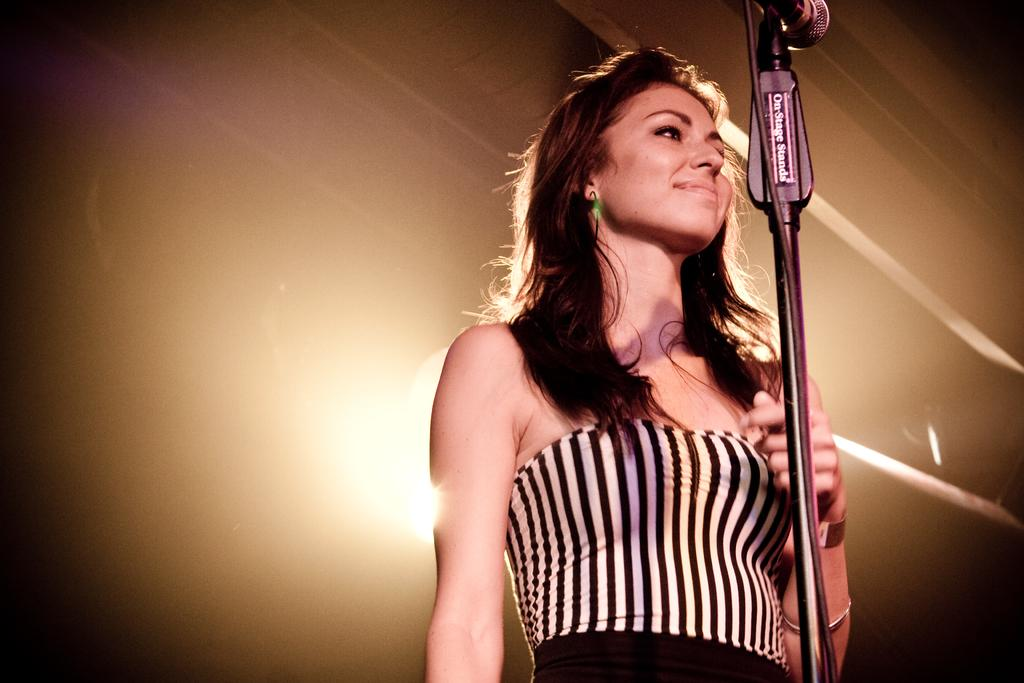What is the main subject of the image? There is a woman standing in the image. What is the woman wearing? The woman is wearing a black and white dress. What object is in front of the woman? There is a microphone in front of the woman. What can be seen in the background of the image? There is a light in the background of the image. What type of seed is the woman planting in the image? There is no seed or planting activity present in the image. What is the woman using to scare away birds in the image? There is no scarecrow or bird-scaring activity present in the image. 